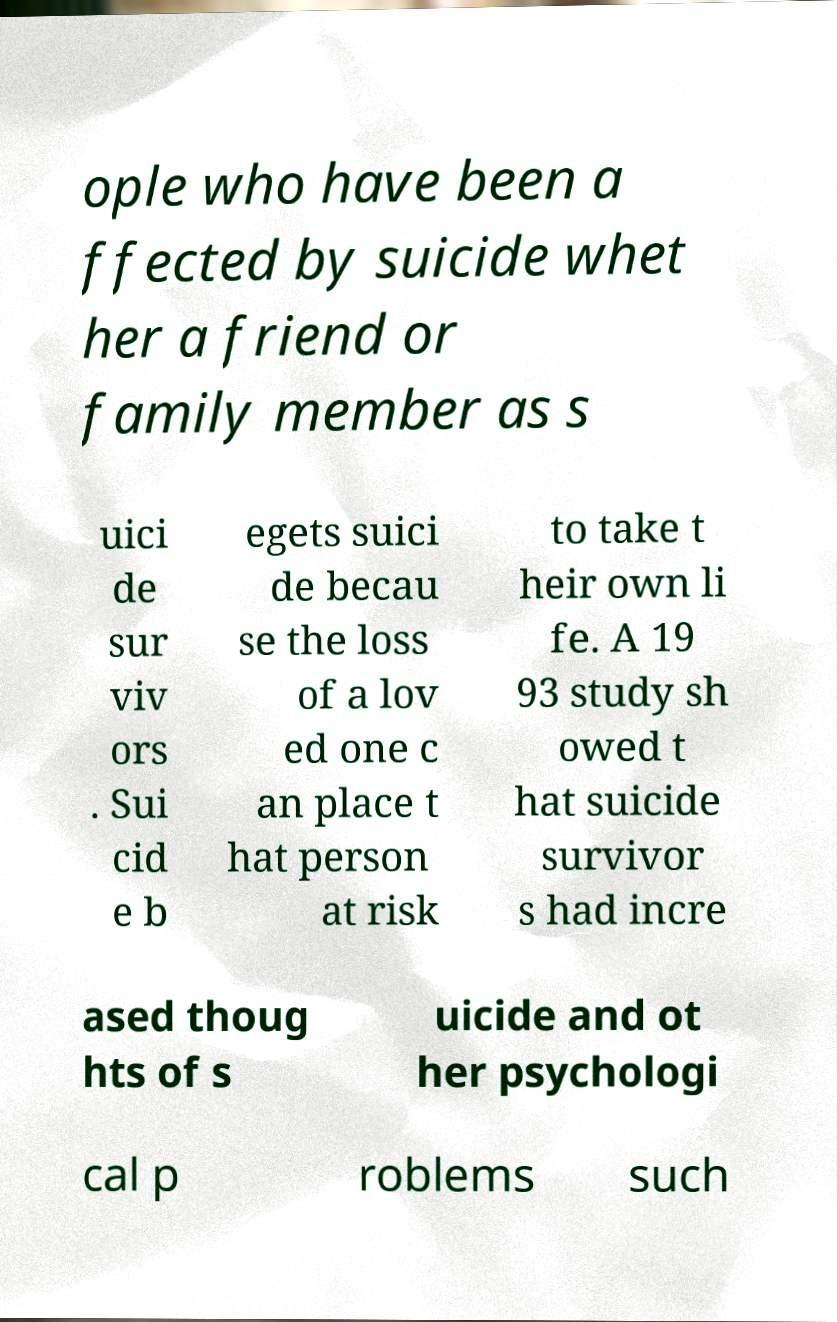Can you accurately transcribe the text from the provided image for me? ople who have been a ffected by suicide whet her a friend or family member as s uici de sur viv ors . Sui cid e b egets suici de becau se the loss of a lov ed one c an place t hat person at risk to take t heir own li fe. A 19 93 study sh owed t hat suicide survivor s had incre ased thoug hts of s uicide and ot her psychologi cal p roblems such 